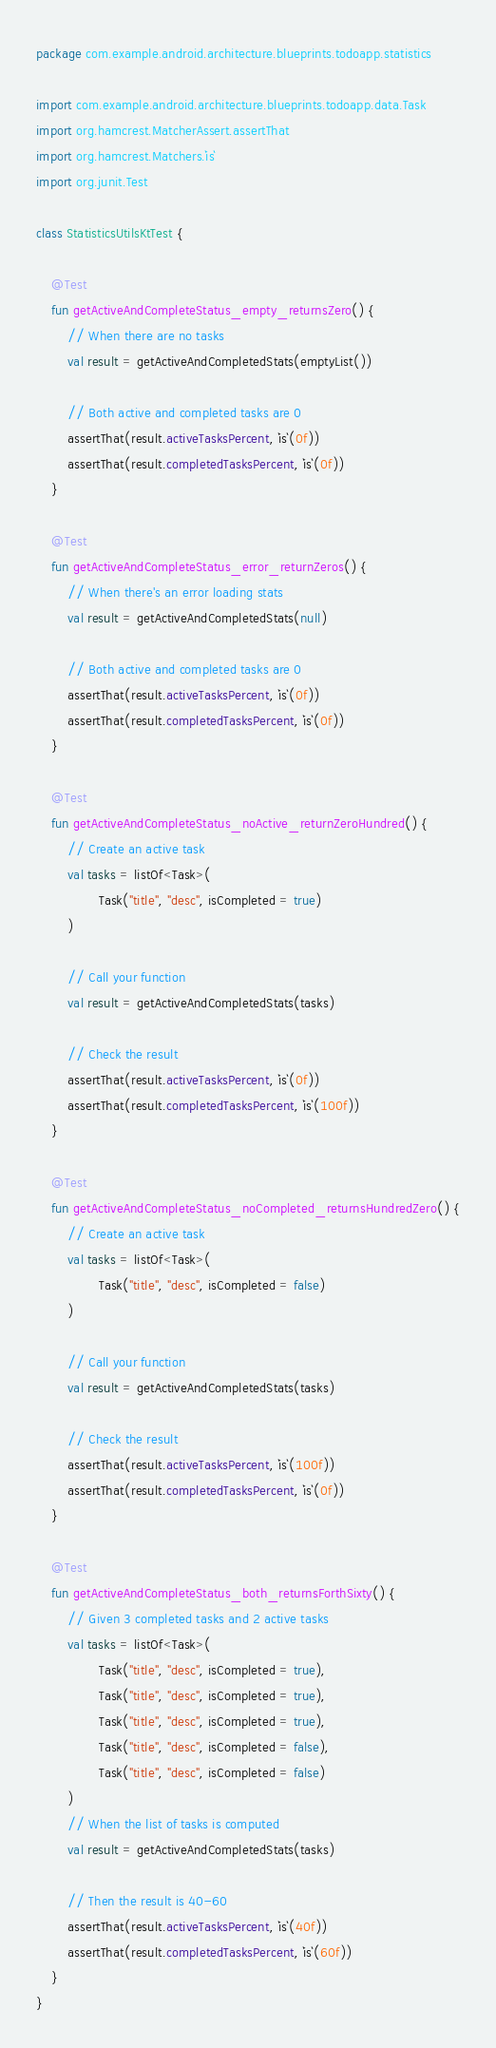Convert code to text. <code><loc_0><loc_0><loc_500><loc_500><_Kotlin_>package com.example.android.architecture.blueprints.todoapp.statistics

import com.example.android.architecture.blueprints.todoapp.data.Task
import org.hamcrest.MatcherAssert.assertThat
import org.hamcrest.Matchers.`is`
import org.junit.Test

class StatisticsUtilsKtTest {

    @Test
    fun getActiveAndCompleteStatus_empty_returnsZero() {
        // When there are no tasks
        val result = getActiveAndCompletedStats(emptyList())

        // Both active and completed tasks are 0
        assertThat(result.activeTasksPercent, `is`(0f))
        assertThat(result.completedTasksPercent, `is`(0f))
    }

    @Test
    fun getActiveAndCompleteStatus_error_returnZeros() {
        // When there's an error loading stats
        val result = getActiveAndCompletedStats(null)

        // Both active and completed tasks are 0
        assertThat(result.activeTasksPercent, `is`(0f))
        assertThat(result.completedTasksPercent, `is`(0f))
    }

    @Test
    fun getActiveAndCompleteStatus_noActive_returnZeroHundred() {
        // Create an active task
        val tasks = listOf<Task>(
                Task("title", "desc", isCompleted = true)
        )

        // Call your function
        val result = getActiveAndCompletedStats(tasks)

        // Check the result
        assertThat(result.activeTasksPercent, `is`(0f))
        assertThat(result.completedTasksPercent, `is`(100f))
    }

    @Test
    fun getActiveAndCompleteStatus_noCompleted_returnsHundredZero() {
        // Create an active task
        val tasks = listOf<Task>(
                Task("title", "desc", isCompleted = false)
        )

        // Call your function
        val result = getActiveAndCompletedStats(tasks)

        // Check the result
        assertThat(result.activeTasksPercent, `is`(100f))
        assertThat(result.completedTasksPercent, `is`(0f))
    }

    @Test
    fun getActiveAndCompleteStatus_both_returnsForthSixty() {
        // Given 3 completed tasks and 2 active tasks
        val tasks = listOf<Task>(
                Task("title", "desc", isCompleted = true),
                Task("title", "desc", isCompleted = true),
                Task("title", "desc", isCompleted = true),
                Task("title", "desc", isCompleted = false),
                Task("title", "desc", isCompleted = false)
        )
        // When the list of tasks is computed
        val result = getActiveAndCompletedStats(tasks)

        // Then the result is 40-60
        assertThat(result.activeTasksPercent, `is`(40f))
        assertThat(result.completedTasksPercent, `is`(60f))
    }
}</code> 